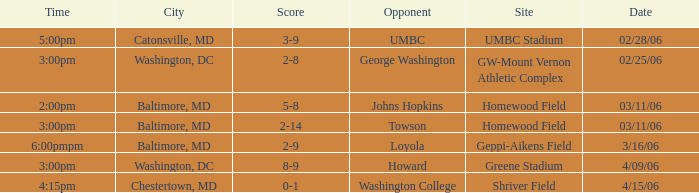Who is the Opponent when the Score is 2-8? George Washington. Write the full table. {'header': ['Time', 'City', 'Score', 'Opponent', 'Site', 'Date'], 'rows': [['5:00pm', 'Catonsville, MD', '3-9', 'UMBC', 'UMBC Stadium', '02/28/06'], ['3:00pm', 'Washington, DC', '2-8', 'George Washington', 'GW-Mount Vernon Athletic Complex', '02/25/06'], ['2:00pm', 'Baltimore, MD', '5-8', 'Johns Hopkins', 'Homewood Field', '03/11/06'], ['3:00pm', 'Baltimore, MD', '2-14', 'Towson', 'Homewood Field', '03/11/06'], ['6:00pmpm', 'Baltimore, MD', '2-9', 'Loyola', 'Geppi-Aikens Field', '3/16/06'], ['3:00pm', 'Washington, DC', '8-9', 'Howard', 'Greene Stadium', '4/09/06'], ['4:15pm', 'Chestertown, MD', '0-1', 'Washington College', 'Shriver Field', '4/15/06']]} 